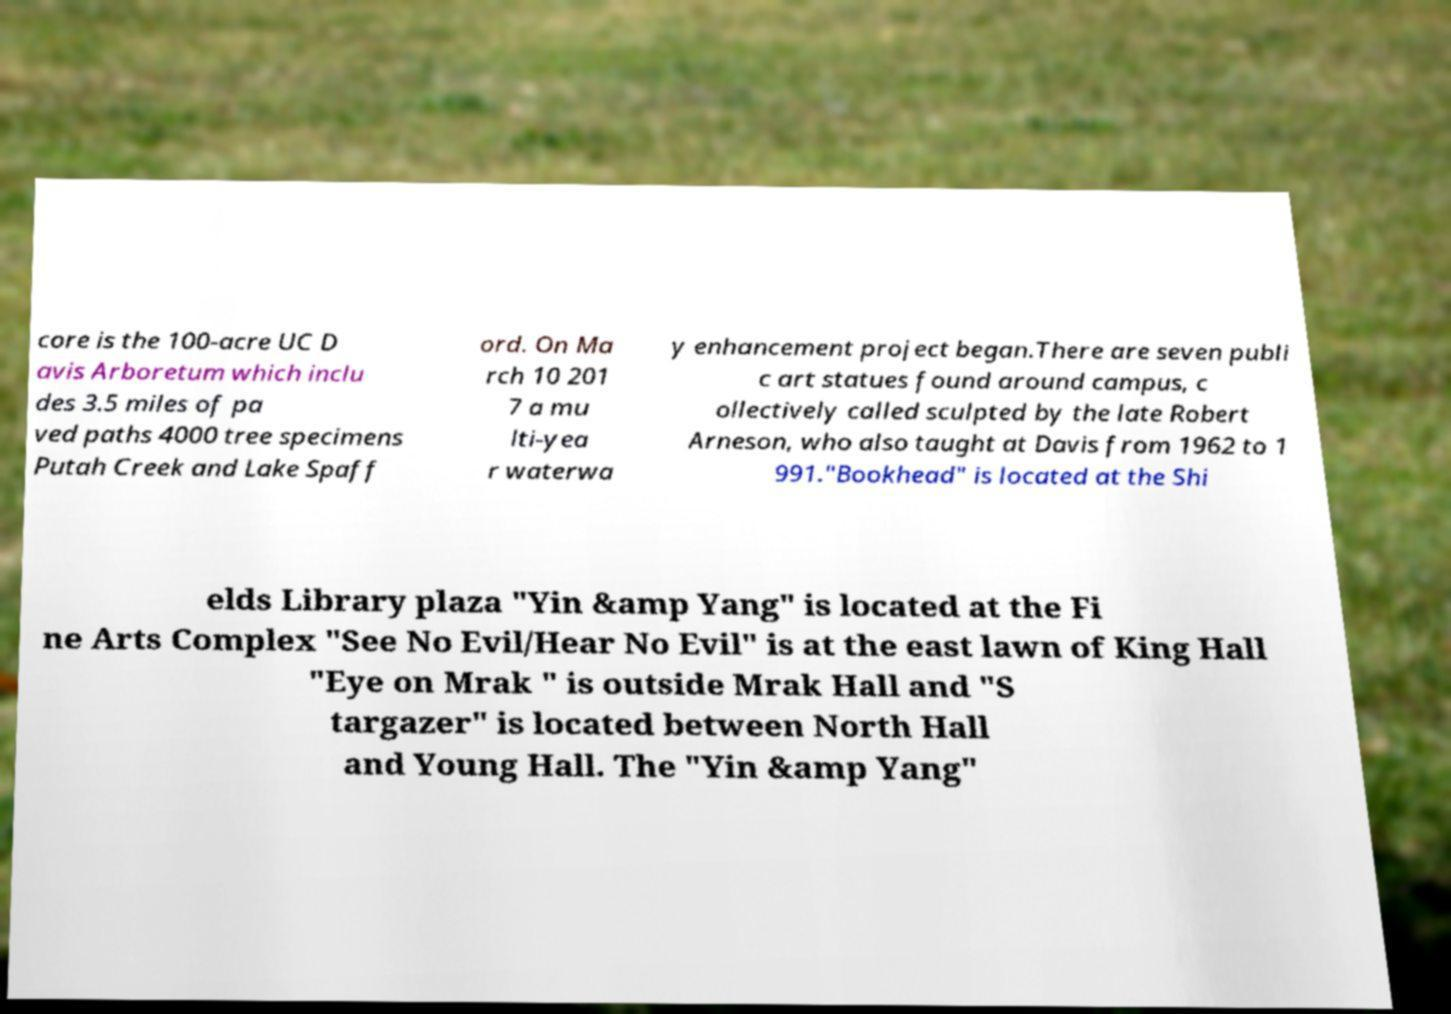There's text embedded in this image that I need extracted. Can you transcribe it verbatim? core is the 100-acre UC D avis Arboretum which inclu des 3.5 miles of pa ved paths 4000 tree specimens Putah Creek and Lake Spaff ord. On Ma rch 10 201 7 a mu lti-yea r waterwa y enhancement project began.There are seven publi c art statues found around campus, c ollectively called sculpted by the late Robert Arneson, who also taught at Davis from 1962 to 1 991."Bookhead" is located at the Shi elds Library plaza "Yin &amp Yang" is located at the Fi ne Arts Complex "See No Evil/Hear No Evil" is at the east lawn of King Hall "Eye on Mrak " is outside Mrak Hall and "S targazer" is located between North Hall and Young Hall. The "Yin &amp Yang" 